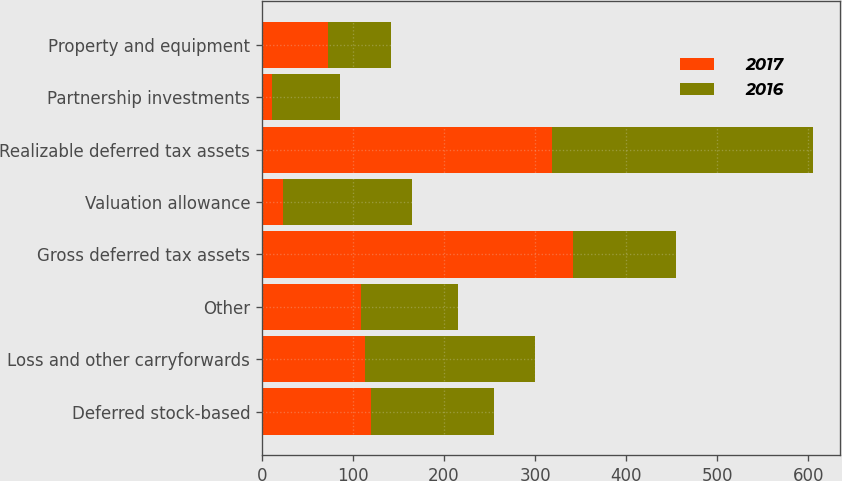Convert chart to OTSL. <chart><loc_0><loc_0><loc_500><loc_500><stacked_bar_chart><ecel><fcel>Deferred stock-based<fcel>Loss and other carryforwards<fcel>Other<fcel>Gross deferred tax assets<fcel>Valuation allowance<fcel>Realizable deferred tax assets<fcel>Partnership investments<fcel>Property and equipment<nl><fcel>2017<fcel>119.6<fcel>113<fcel>109.2<fcel>341.8<fcel>23.6<fcel>318.2<fcel>11.5<fcel>72.9<nl><fcel>2016<fcel>135<fcel>187.2<fcel>106.1<fcel>113<fcel>141.6<fcel>286.7<fcel>74.2<fcel>69.4<nl></chart> 